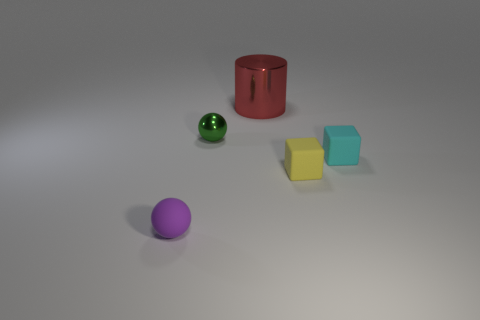What number of small cyan things are the same shape as the tiny green metal object?
Your answer should be compact. 0. Does the cylinder have the same color as the tiny shiny ball?
Make the answer very short. No. Is the number of small brown metallic things less than the number of balls?
Offer a very short reply. Yes. What material is the ball behind the yellow rubber block?
Your answer should be very brief. Metal. There is a purple ball that is the same size as the yellow thing; what material is it?
Keep it short and to the point. Rubber. What material is the tiny ball that is in front of the small sphere behind the ball that is in front of the small green shiny object?
Provide a succinct answer. Rubber. Is the size of the matte cube that is left of the cyan matte thing the same as the metallic cylinder?
Your response must be concise. No. Are there more small gray metal cylinders than cyan matte cubes?
Keep it short and to the point. No. How many tiny things are either matte blocks or red metal cylinders?
Keep it short and to the point. 2. What number of other things are there of the same color as the metal sphere?
Your response must be concise. 0. 